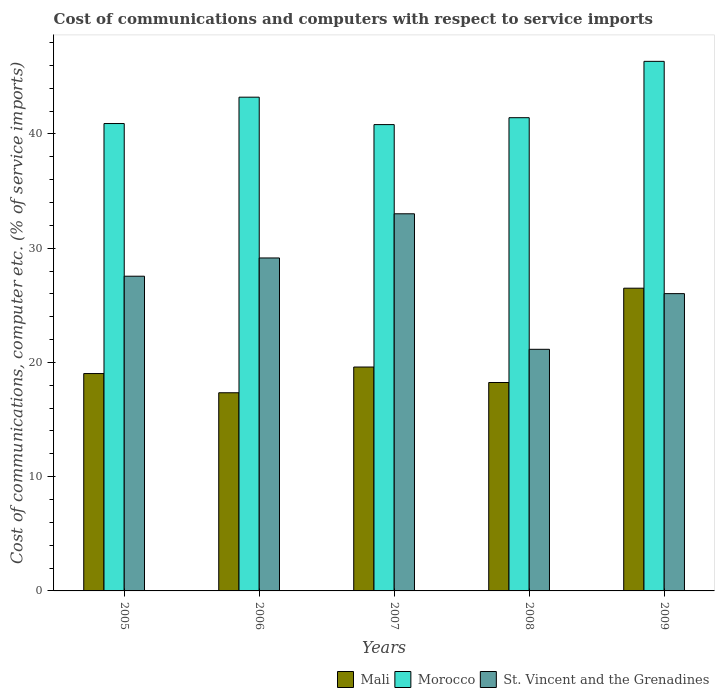How many groups of bars are there?
Your response must be concise. 5. Are the number of bars per tick equal to the number of legend labels?
Your answer should be very brief. Yes. Are the number of bars on each tick of the X-axis equal?
Make the answer very short. Yes. What is the label of the 1st group of bars from the left?
Provide a succinct answer. 2005. What is the cost of communications and computers in Morocco in 2008?
Give a very brief answer. 41.42. Across all years, what is the maximum cost of communications and computers in St. Vincent and the Grenadines?
Your response must be concise. 33.01. Across all years, what is the minimum cost of communications and computers in Morocco?
Offer a terse response. 40.82. In which year was the cost of communications and computers in Morocco minimum?
Your answer should be very brief. 2007. What is the total cost of communications and computers in Morocco in the graph?
Offer a very short reply. 212.73. What is the difference between the cost of communications and computers in St. Vincent and the Grenadines in 2007 and that in 2008?
Your answer should be compact. 11.86. What is the difference between the cost of communications and computers in St. Vincent and the Grenadines in 2005 and the cost of communications and computers in Morocco in 2006?
Ensure brevity in your answer.  -15.67. What is the average cost of communications and computers in St. Vincent and the Grenadines per year?
Offer a terse response. 27.38. In the year 2006, what is the difference between the cost of communications and computers in Mali and cost of communications and computers in St. Vincent and the Grenadines?
Keep it short and to the point. -11.8. What is the ratio of the cost of communications and computers in Morocco in 2008 to that in 2009?
Provide a short and direct response. 0.89. Is the difference between the cost of communications and computers in Mali in 2006 and 2009 greater than the difference between the cost of communications and computers in St. Vincent and the Grenadines in 2006 and 2009?
Provide a short and direct response. No. What is the difference between the highest and the second highest cost of communications and computers in Mali?
Provide a succinct answer. 6.9. What is the difference between the highest and the lowest cost of communications and computers in Mali?
Provide a short and direct response. 9.15. Is the sum of the cost of communications and computers in Morocco in 2005 and 2007 greater than the maximum cost of communications and computers in St. Vincent and the Grenadines across all years?
Provide a succinct answer. Yes. What does the 1st bar from the left in 2007 represents?
Make the answer very short. Mali. What does the 3rd bar from the right in 2007 represents?
Give a very brief answer. Mali. Is it the case that in every year, the sum of the cost of communications and computers in Morocco and cost of communications and computers in Mali is greater than the cost of communications and computers in St. Vincent and the Grenadines?
Give a very brief answer. Yes. How many bars are there?
Your answer should be very brief. 15. Are all the bars in the graph horizontal?
Your answer should be very brief. No. How many years are there in the graph?
Keep it short and to the point. 5. What is the difference between two consecutive major ticks on the Y-axis?
Your answer should be very brief. 10. Does the graph contain grids?
Offer a very short reply. No. What is the title of the graph?
Give a very brief answer. Cost of communications and computers with respect to service imports. What is the label or title of the X-axis?
Provide a short and direct response. Years. What is the label or title of the Y-axis?
Offer a terse response. Cost of communications, computer etc. (% of service imports). What is the Cost of communications, computer etc. (% of service imports) of Mali in 2005?
Your answer should be compact. 19.03. What is the Cost of communications, computer etc. (% of service imports) of Morocco in 2005?
Your answer should be very brief. 40.91. What is the Cost of communications, computer etc. (% of service imports) in St. Vincent and the Grenadines in 2005?
Make the answer very short. 27.55. What is the Cost of communications, computer etc. (% of service imports) in Mali in 2006?
Offer a very short reply. 17.35. What is the Cost of communications, computer etc. (% of service imports) in Morocco in 2006?
Keep it short and to the point. 43.22. What is the Cost of communications, computer etc. (% of service imports) of St. Vincent and the Grenadines in 2006?
Offer a very short reply. 29.15. What is the Cost of communications, computer etc. (% of service imports) in Mali in 2007?
Provide a short and direct response. 19.6. What is the Cost of communications, computer etc. (% of service imports) of Morocco in 2007?
Your response must be concise. 40.82. What is the Cost of communications, computer etc. (% of service imports) of St. Vincent and the Grenadines in 2007?
Offer a terse response. 33.01. What is the Cost of communications, computer etc. (% of service imports) in Mali in 2008?
Keep it short and to the point. 18.24. What is the Cost of communications, computer etc. (% of service imports) of Morocco in 2008?
Your answer should be compact. 41.42. What is the Cost of communications, computer etc. (% of service imports) of St. Vincent and the Grenadines in 2008?
Make the answer very short. 21.15. What is the Cost of communications, computer etc. (% of service imports) of Mali in 2009?
Ensure brevity in your answer.  26.5. What is the Cost of communications, computer etc. (% of service imports) of Morocco in 2009?
Keep it short and to the point. 46.36. What is the Cost of communications, computer etc. (% of service imports) of St. Vincent and the Grenadines in 2009?
Keep it short and to the point. 26.02. Across all years, what is the maximum Cost of communications, computer etc. (% of service imports) in Mali?
Provide a short and direct response. 26.5. Across all years, what is the maximum Cost of communications, computer etc. (% of service imports) of Morocco?
Keep it short and to the point. 46.36. Across all years, what is the maximum Cost of communications, computer etc. (% of service imports) in St. Vincent and the Grenadines?
Offer a very short reply. 33.01. Across all years, what is the minimum Cost of communications, computer etc. (% of service imports) of Mali?
Your response must be concise. 17.35. Across all years, what is the minimum Cost of communications, computer etc. (% of service imports) of Morocco?
Give a very brief answer. 40.82. Across all years, what is the minimum Cost of communications, computer etc. (% of service imports) of St. Vincent and the Grenadines?
Offer a terse response. 21.15. What is the total Cost of communications, computer etc. (% of service imports) of Mali in the graph?
Your answer should be compact. 100.72. What is the total Cost of communications, computer etc. (% of service imports) of Morocco in the graph?
Your answer should be very brief. 212.73. What is the total Cost of communications, computer etc. (% of service imports) in St. Vincent and the Grenadines in the graph?
Your answer should be compact. 136.88. What is the difference between the Cost of communications, computer etc. (% of service imports) of Mali in 2005 and that in 2006?
Your answer should be compact. 1.68. What is the difference between the Cost of communications, computer etc. (% of service imports) in Morocco in 2005 and that in 2006?
Provide a succinct answer. -2.31. What is the difference between the Cost of communications, computer etc. (% of service imports) of St. Vincent and the Grenadines in 2005 and that in 2006?
Offer a terse response. -1.6. What is the difference between the Cost of communications, computer etc. (% of service imports) of Mali in 2005 and that in 2007?
Offer a terse response. -0.57. What is the difference between the Cost of communications, computer etc. (% of service imports) of Morocco in 2005 and that in 2007?
Your answer should be very brief. 0.09. What is the difference between the Cost of communications, computer etc. (% of service imports) in St. Vincent and the Grenadines in 2005 and that in 2007?
Offer a terse response. -5.46. What is the difference between the Cost of communications, computer etc. (% of service imports) in Mali in 2005 and that in 2008?
Ensure brevity in your answer.  0.78. What is the difference between the Cost of communications, computer etc. (% of service imports) in Morocco in 2005 and that in 2008?
Provide a short and direct response. -0.51. What is the difference between the Cost of communications, computer etc. (% of service imports) in St. Vincent and the Grenadines in 2005 and that in 2008?
Provide a succinct answer. 6.4. What is the difference between the Cost of communications, computer etc. (% of service imports) in Mali in 2005 and that in 2009?
Offer a terse response. -7.47. What is the difference between the Cost of communications, computer etc. (% of service imports) in Morocco in 2005 and that in 2009?
Ensure brevity in your answer.  -5.44. What is the difference between the Cost of communications, computer etc. (% of service imports) in St. Vincent and the Grenadines in 2005 and that in 2009?
Your response must be concise. 1.52. What is the difference between the Cost of communications, computer etc. (% of service imports) in Mali in 2006 and that in 2007?
Make the answer very short. -2.25. What is the difference between the Cost of communications, computer etc. (% of service imports) in Morocco in 2006 and that in 2007?
Your response must be concise. 2.4. What is the difference between the Cost of communications, computer etc. (% of service imports) in St. Vincent and the Grenadines in 2006 and that in 2007?
Offer a very short reply. -3.87. What is the difference between the Cost of communications, computer etc. (% of service imports) of Mali in 2006 and that in 2008?
Your answer should be compact. -0.9. What is the difference between the Cost of communications, computer etc. (% of service imports) in Morocco in 2006 and that in 2008?
Keep it short and to the point. 1.8. What is the difference between the Cost of communications, computer etc. (% of service imports) of St. Vincent and the Grenadines in 2006 and that in 2008?
Keep it short and to the point. 8. What is the difference between the Cost of communications, computer etc. (% of service imports) in Mali in 2006 and that in 2009?
Make the answer very short. -9.15. What is the difference between the Cost of communications, computer etc. (% of service imports) in Morocco in 2006 and that in 2009?
Your response must be concise. -3.14. What is the difference between the Cost of communications, computer etc. (% of service imports) of St. Vincent and the Grenadines in 2006 and that in 2009?
Offer a very short reply. 3.12. What is the difference between the Cost of communications, computer etc. (% of service imports) in Mali in 2007 and that in 2008?
Make the answer very short. 1.36. What is the difference between the Cost of communications, computer etc. (% of service imports) of Morocco in 2007 and that in 2008?
Your answer should be compact. -0.6. What is the difference between the Cost of communications, computer etc. (% of service imports) of St. Vincent and the Grenadines in 2007 and that in 2008?
Keep it short and to the point. 11.86. What is the difference between the Cost of communications, computer etc. (% of service imports) of Mali in 2007 and that in 2009?
Your answer should be compact. -6.9. What is the difference between the Cost of communications, computer etc. (% of service imports) in Morocco in 2007 and that in 2009?
Offer a very short reply. -5.54. What is the difference between the Cost of communications, computer etc. (% of service imports) of St. Vincent and the Grenadines in 2007 and that in 2009?
Provide a short and direct response. 6.99. What is the difference between the Cost of communications, computer etc. (% of service imports) of Mali in 2008 and that in 2009?
Your answer should be compact. -8.25. What is the difference between the Cost of communications, computer etc. (% of service imports) in Morocco in 2008 and that in 2009?
Give a very brief answer. -4.93. What is the difference between the Cost of communications, computer etc. (% of service imports) of St. Vincent and the Grenadines in 2008 and that in 2009?
Provide a succinct answer. -4.87. What is the difference between the Cost of communications, computer etc. (% of service imports) of Mali in 2005 and the Cost of communications, computer etc. (% of service imports) of Morocco in 2006?
Give a very brief answer. -24.19. What is the difference between the Cost of communications, computer etc. (% of service imports) of Mali in 2005 and the Cost of communications, computer etc. (% of service imports) of St. Vincent and the Grenadines in 2006?
Offer a terse response. -10.12. What is the difference between the Cost of communications, computer etc. (% of service imports) of Morocco in 2005 and the Cost of communications, computer etc. (% of service imports) of St. Vincent and the Grenadines in 2006?
Your answer should be very brief. 11.77. What is the difference between the Cost of communications, computer etc. (% of service imports) in Mali in 2005 and the Cost of communications, computer etc. (% of service imports) in Morocco in 2007?
Your answer should be very brief. -21.79. What is the difference between the Cost of communications, computer etc. (% of service imports) in Mali in 2005 and the Cost of communications, computer etc. (% of service imports) in St. Vincent and the Grenadines in 2007?
Give a very brief answer. -13.98. What is the difference between the Cost of communications, computer etc. (% of service imports) in Morocco in 2005 and the Cost of communications, computer etc. (% of service imports) in St. Vincent and the Grenadines in 2007?
Offer a terse response. 7.9. What is the difference between the Cost of communications, computer etc. (% of service imports) in Mali in 2005 and the Cost of communications, computer etc. (% of service imports) in Morocco in 2008?
Provide a succinct answer. -22.4. What is the difference between the Cost of communications, computer etc. (% of service imports) in Mali in 2005 and the Cost of communications, computer etc. (% of service imports) in St. Vincent and the Grenadines in 2008?
Your answer should be compact. -2.12. What is the difference between the Cost of communications, computer etc. (% of service imports) in Morocco in 2005 and the Cost of communications, computer etc. (% of service imports) in St. Vincent and the Grenadines in 2008?
Your response must be concise. 19.76. What is the difference between the Cost of communications, computer etc. (% of service imports) of Mali in 2005 and the Cost of communications, computer etc. (% of service imports) of Morocco in 2009?
Your answer should be compact. -27.33. What is the difference between the Cost of communications, computer etc. (% of service imports) of Mali in 2005 and the Cost of communications, computer etc. (% of service imports) of St. Vincent and the Grenadines in 2009?
Provide a short and direct response. -7. What is the difference between the Cost of communications, computer etc. (% of service imports) in Morocco in 2005 and the Cost of communications, computer etc. (% of service imports) in St. Vincent and the Grenadines in 2009?
Offer a very short reply. 14.89. What is the difference between the Cost of communications, computer etc. (% of service imports) in Mali in 2006 and the Cost of communications, computer etc. (% of service imports) in Morocco in 2007?
Ensure brevity in your answer.  -23.47. What is the difference between the Cost of communications, computer etc. (% of service imports) in Mali in 2006 and the Cost of communications, computer etc. (% of service imports) in St. Vincent and the Grenadines in 2007?
Your answer should be compact. -15.67. What is the difference between the Cost of communications, computer etc. (% of service imports) of Morocco in 2006 and the Cost of communications, computer etc. (% of service imports) of St. Vincent and the Grenadines in 2007?
Provide a short and direct response. 10.21. What is the difference between the Cost of communications, computer etc. (% of service imports) of Mali in 2006 and the Cost of communications, computer etc. (% of service imports) of Morocco in 2008?
Your answer should be very brief. -24.08. What is the difference between the Cost of communications, computer etc. (% of service imports) of Mali in 2006 and the Cost of communications, computer etc. (% of service imports) of St. Vincent and the Grenadines in 2008?
Provide a short and direct response. -3.8. What is the difference between the Cost of communications, computer etc. (% of service imports) of Morocco in 2006 and the Cost of communications, computer etc. (% of service imports) of St. Vincent and the Grenadines in 2008?
Your answer should be compact. 22.07. What is the difference between the Cost of communications, computer etc. (% of service imports) of Mali in 2006 and the Cost of communications, computer etc. (% of service imports) of Morocco in 2009?
Your answer should be compact. -29.01. What is the difference between the Cost of communications, computer etc. (% of service imports) in Mali in 2006 and the Cost of communications, computer etc. (% of service imports) in St. Vincent and the Grenadines in 2009?
Your answer should be very brief. -8.68. What is the difference between the Cost of communications, computer etc. (% of service imports) of Morocco in 2006 and the Cost of communications, computer etc. (% of service imports) of St. Vincent and the Grenadines in 2009?
Give a very brief answer. 17.2. What is the difference between the Cost of communications, computer etc. (% of service imports) in Mali in 2007 and the Cost of communications, computer etc. (% of service imports) in Morocco in 2008?
Keep it short and to the point. -21.82. What is the difference between the Cost of communications, computer etc. (% of service imports) in Mali in 2007 and the Cost of communications, computer etc. (% of service imports) in St. Vincent and the Grenadines in 2008?
Give a very brief answer. -1.55. What is the difference between the Cost of communications, computer etc. (% of service imports) in Morocco in 2007 and the Cost of communications, computer etc. (% of service imports) in St. Vincent and the Grenadines in 2008?
Offer a terse response. 19.67. What is the difference between the Cost of communications, computer etc. (% of service imports) of Mali in 2007 and the Cost of communications, computer etc. (% of service imports) of Morocco in 2009?
Make the answer very short. -26.76. What is the difference between the Cost of communications, computer etc. (% of service imports) of Mali in 2007 and the Cost of communications, computer etc. (% of service imports) of St. Vincent and the Grenadines in 2009?
Ensure brevity in your answer.  -6.42. What is the difference between the Cost of communications, computer etc. (% of service imports) in Morocco in 2007 and the Cost of communications, computer etc. (% of service imports) in St. Vincent and the Grenadines in 2009?
Provide a short and direct response. 14.8. What is the difference between the Cost of communications, computer etc. (% of service imports) of Mali in 2008 and the Cost of communications, computer etc. (% of service imports) of Morocco in 2009?
Make the answer very short. -28.11. What is the difference between the Cost of communications, computer etc. (% of service imports) of Mali in 2008 and the Cost of communications, computer etc. (% of service imports) of St. Vincent and the Grenadines in 2009?
Your response must be concise. -7.78. What is the difference between the Cost of communications, computer etc. (% of service imports) in Morocco in 2008 and the Cost of communications, computer etc. (% of service imports) in St. Vincent and the Grenadines in 2009?
Give a very brief answer. 15.4. What is the average Cost of communications, computer etc. (% of service imports) of Mali per year?
Your answer should be compact. 20.14. What is the average Cost of communications, computer etc. (% of service imports) of Morocco per year?
Offer a terse response. 42.55. What is the average Cost of communications, computer etc. (% of service imports) in St. Vincent and the Grenadines per year?
Offer a very short reply. 27.38. In the year 2005, what is the difference between the Cost of communications, computer etc. (% of service imports) in Mali and Cost of communications, computer etc. (% of service imports) in Morocco?
Provide a short and direct response. -21.88. In the year 2005, what is the difference between the Cost of communications, computer etc. (% of service imports) in Mali and Cost of communications, computer etc. (% of service imports) in St. Vincent and the Grenadines?
Your answer should be compact. -8.52. In the year 2005, what is the difference between the Cost of communications, computer etc. (% of service imports) of Morocco and Cost of communications, computer etc. (% of service imports) of St. Vincent and the Grenadines?
Your response must be concise. 13.36. In the year 2006, what is the difference between the Cost of communications, computer etc. (% of service imports) in Mali and Cost of communications, computer etc. (% of service imports) in Morocco?
Ensure brevity in your answer.  -25.87. In the year 2006, what is the difference between the Cost of communications, computer etc. (% of service imports) of Mali and Cost of communications, computer etc. (% of service imports) of St. Vincent and the Grenadines?
Make the answer very short. -11.8. In the year 2006, what is the difference between the Cost of communications, computer etc. (% of service imports) of Morocco and Cost of communications, computer etc. (% of service imports) of St. Vincent and the Grenadines?
Provide a succinct answer. 14.07. In the year 2007, what is the difference between the Cost of communications, computer etc. (% of service imports) in Mali and Cost of communications, computer etc. (% of service imports) in Morocco?
Your answer should be compact. -21.22. In the year 2007, what is the difference between the Cost of communications, computer etc. (% of service imports) of Mali and Cost of communications, computer etc. (% of service imports) of St. Vincent and the Grenadines?
Make the answer very short. -13.41. In the year 2007, what is the difference between the Cost of communications, computer etc. (% of service imports) of Morocco and Cost of communications, computer etc. (% of service imports) of St. Vincent and the Grenadines?
Ensure brevity in your answer.  7.81. In the year 2008, what is the difference between the Cost of communications, computer etc. (% of service imports) of Mali and Cost of communications, computer etc. (% of service imports) of Morocco?
Provide a short and direct response. -23.18. In the year 2008, what is the difference between the Cost of communications, computer etc. (% of service imports) in Mali and Cost of communications, computer etc. (% of service imports) in St. Vincent and the Grenadines?
Make the answer very short. -2.91. In the year 2008, what is the difference between the Cost of communications, computer etc. (% of service imports) of Morocco and Cost of communications, computer etc. (% of service imports) of St. Vincent and the Grenadines?
Ensure brevity in your answer.  20.27. In the year 2009, what is the difference between the Cost of communications, computer etc. (% of service imports) of Mali and Cost of communications, computer etc. (% of service imports) of Morocco?
Your answer should be compact. -19.86. In the year 2009, what is the difference between the Cost of communications, computer etc. (% of service imports) in Mali and Cost of communications, computer etc. (% of service imports) in St. Vincent and the Grenadines?
Offer a terse response. 0.47. In the year 2009, what is the difference between the Cost of communications, computer etc. (% of service imports) in Morocco and Cost of communications, computer etc. (% of service imports) in St. Vincent and the Grenadines?
Your answer should be compact. 20.33. What is the ratio of the Cost of communications, computer etc. (% of service imports) of Mali in 2005 to that in 2006?
Make the answer very short. 1.1. What is the ratio of the Cost of communications, computer etc. (% of service imports) of Morocco in 2005 to that in 2006?
Provide a short and direct response. 0.95. What is the ratio of the Cost of communications, computer etc. (% of service imports) in St. Vincent and the Grenadines in 2005 to that in 2006?
Your answer should be compact. 0.95. What is the ratio of the Cost of communications, computer etc. (% of service imports) of Mali in 2005 to that in 2007?
Make the answer very short. 0.97. What is the ratio of the Cost of communications, computer etc. (% of service imports) in St. Vincent and the Grenadines in 2005 to that in 2007?
Your answer should be very brief. 0.83. What is the ratio of the Cost of communications, computer etc. (% of service imports) in Mali in 2005 to that in 2008?
Keep it short and to the point. 1.04. What is the ratio of the Cost of communications, computer etc. (% of service imports) in Morocco in 2005 to that in 2008?
Your response must be concise. 0.99. What is the ratio of the Cost of communications, computer etc. (% of service imports) in St. Vincent and the Grenadines in 2005 to that in 2008?
Your answer should be compact. 1.3. What is the ratio of the Cost of communications, computer etc. (% of service imports) of Mali in 2005 to that in 2009?
Your answer should be very brief. 0.72. What is the ratio of the Cost of communications, computer etc. (% of service imports) of Morocco in 2005 to that in 2009?
Ensure brevity in your answer.  0.88. What is the ratio of the Cost of communications, computer etc. (% of service imports) in St. Vincent and the Grenadines in 2005 to that in 2009?
Your answer should be compact. 1.06. What is the ratio of the Cost of communications, computer etc. (% of service imports) in Mali in 2006 to that in 2007?
Provide a short and direct response. 0.89. What is the ratio of the Cost of communications, computer etc. (% of service imports) in Morocco in 2006 to that in 2007?
Your answer should be very brief. 1.06. What is the ratio of the Cost of communications, computer etc. (% of service imports) in St. Vincent and the Grenadines in 2006 to that in 2007?
Your response must be concise. 0.88. What is the ratio of the Cost of communications, computer etc. (% of service imports) of Mali in 2006 to that in 2008?
Ensure brevity in your answer.  0.95. What is the ratio of the Cost of communications, computer etc. (% of service imports) of Morocco in 2006 to that in 2008?
Provide a short and direct response. 1.04. What is the ratio of the Cost of communications, computer etc. (% of service imports) of St. Vincent and the Grenadines in 2006 to that in 2008?
Make the answer very short. 1.38. What is the ratio of the Cost of communications, computer etc. (% of service imports) in Mali in 2006 to that in 2009?
Your answer should be very brief. 0.65. What is the ratio of the Cost of communications, computer etc. (% of service imports) in Morocco in 2006 to that in 2009?
Offer a terse response. 0.93. What is the ratio of the Cost of communications, computer etc. (% of service imports) in St. Vincent and the Grenadines in 2006 to that in 2009?
Provide a short and direct response. 1.12. What is the ratio of the Cost of communications, computer etc. (% of service imports) of Mali in 2007 to that in 2008?
Your response must be concise. 1.07. What is the ratio of the Cost of communications, computer etc. (% of service imports) of Morocco in 2007 to that in 2008?
Provide a short and direct response. 0.99. What is the ratio of the Cost of communications, computer etc. (% of service imports) of St. Vincent and the Grenadines in 2007 to that in 2008?
Your response must be concise. 1.56. What is the ratio of the Cost of communications, computer etc. (% of service imports) of Mali in 2007 to that in 2009?
Your answer should be compact. 0.74. What is the ratio of the Cost of communications, computer etc. (% of service imports) of Morocco in 2007 to that in 2009?
Your answer should be very brief. 0.88. What is the ratio of the Cost of communications, computer etc. (% of service imports) of St. Vincent and the Grenadines in 2007 to that in 2009?
Your response must be concise. 1.27. What is the ratio of the Cost of communications, computer etc. (% of service imports) of Mali in 2008 to that in 2009?
Offer a very short reply. 0.69. What is the ratio of the Cost of communications, computer etc. (% of service imports) in Morocco in 2008 to that in 2009?
Your answer should be very brief. 0.89. What is the ratio of the Cost of communications, computer etc. (% of service imports) of St. Vincent and the Grenadines in 2008 to that in 2009?
Give a very brief answer. 0.81. What is the difference between the highest and the second highest Cost of communications, computer etc. (% of service imports) of Mali?
Your answer should be very brief. 6.9. What is the difference between the highest and the second highest Cost of communications, computer etc. (% of service imports) in Morocco?
Your answer should be compact. 3.14. What is the difference between the highest and the second highest Cost of communications, computer etc. (% of service imports) in St. Vincent and the Grenadines?
Offer a very short reply. 3.87. What is the difference between the highest and the lowest Cost of communications, computer etc. (% of service imports) of Mali?
Ensure brevity in your answer.  9.15. What is the difference between the highest and the lowest Cost of communications, computer etc. (% of service imports) of Morocco?
Your answer should be compact. 5.54. What is the difference between the highest and the lowest Cost of communications, computer etc. (% of service imports) of St. Vincent and the Grenadines?
Offer a terse response. 11.86. 